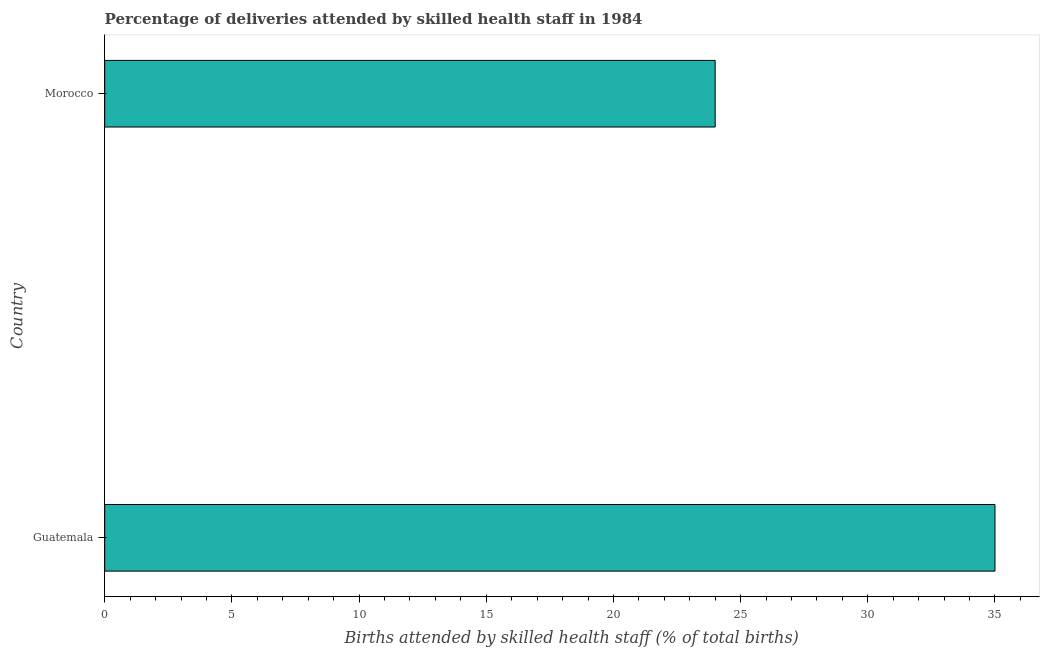Does the graph contain any zero values?
Provide a short and direct response. No. What is the title of the graph?
Offer a very short reply. Percentage of deliveries attended by skilled health staff in 1984. What is the label or title of the X-axis?
Ensure brevity in your answer.  Births attended by skilled health staff (% of total births). What is the label or title of the Y-axis?
Provide a succinct answer. Country. What is the number of births attended by skilled health staff in Morocco?
Provide a short and direct response. 24. Across all countries, what is the minimum number of births attended by skilled health staff?
Make the answer very short. 24. In which country was the number of births attended by skilled health staff maximum?
Your response must be concise. Guatemala. In which country was the number of births attended by skilled health staff minimum?
Ensure brevity in your answer.  Morocco. What is the sum of the number of births attended by skilled health staff?
Offer a very short reply. 59. What is the difference between the number of births attended by skilled health staff in Guatemala and Morocco?
Your answer should be very brief. 11. What is the median number of births attended by skilled health staff?
Keep it short and to the point. 29.5. In how many countries, is the number of births attended by skilled health staff greater than 5 %?
Your answer should be compact. 2. What is the ratio of the number of births attended by skilled health staff in Guatemala to that in Morocco?
Give a very brief answer. 1.46. In how many countries, is the number of births attended by skilled health staff greater than the average number of births attended by skilled health staff taken over all countries?
Provide a succinct answer. 1. Are all the bars in the graph horizontal?
Make the answer very short. Yes. How many countries are there in the graph?
Give a very brief answer. 2. Are the values on the major ticks of X-axis written in scientific E-notation?
Keep it short and to the point. No. What is the Births attended by skilled health staff (% of total births) of Guatemala?
Offer a terse response. 35. What is the Births attended by skilled health staff (% of total births) of Morocco?
Ensure brevity in your answer.  24. What is the difference between the Births attended by skilled health staff (% of total births) in Guatemala and Morocco?
Offer a terse response. 11. What is the ratio of the Births attended by skilled health staff (% of total births) in Guatemala to that in Morocco?
Your answer should be very brief. 1.46. 